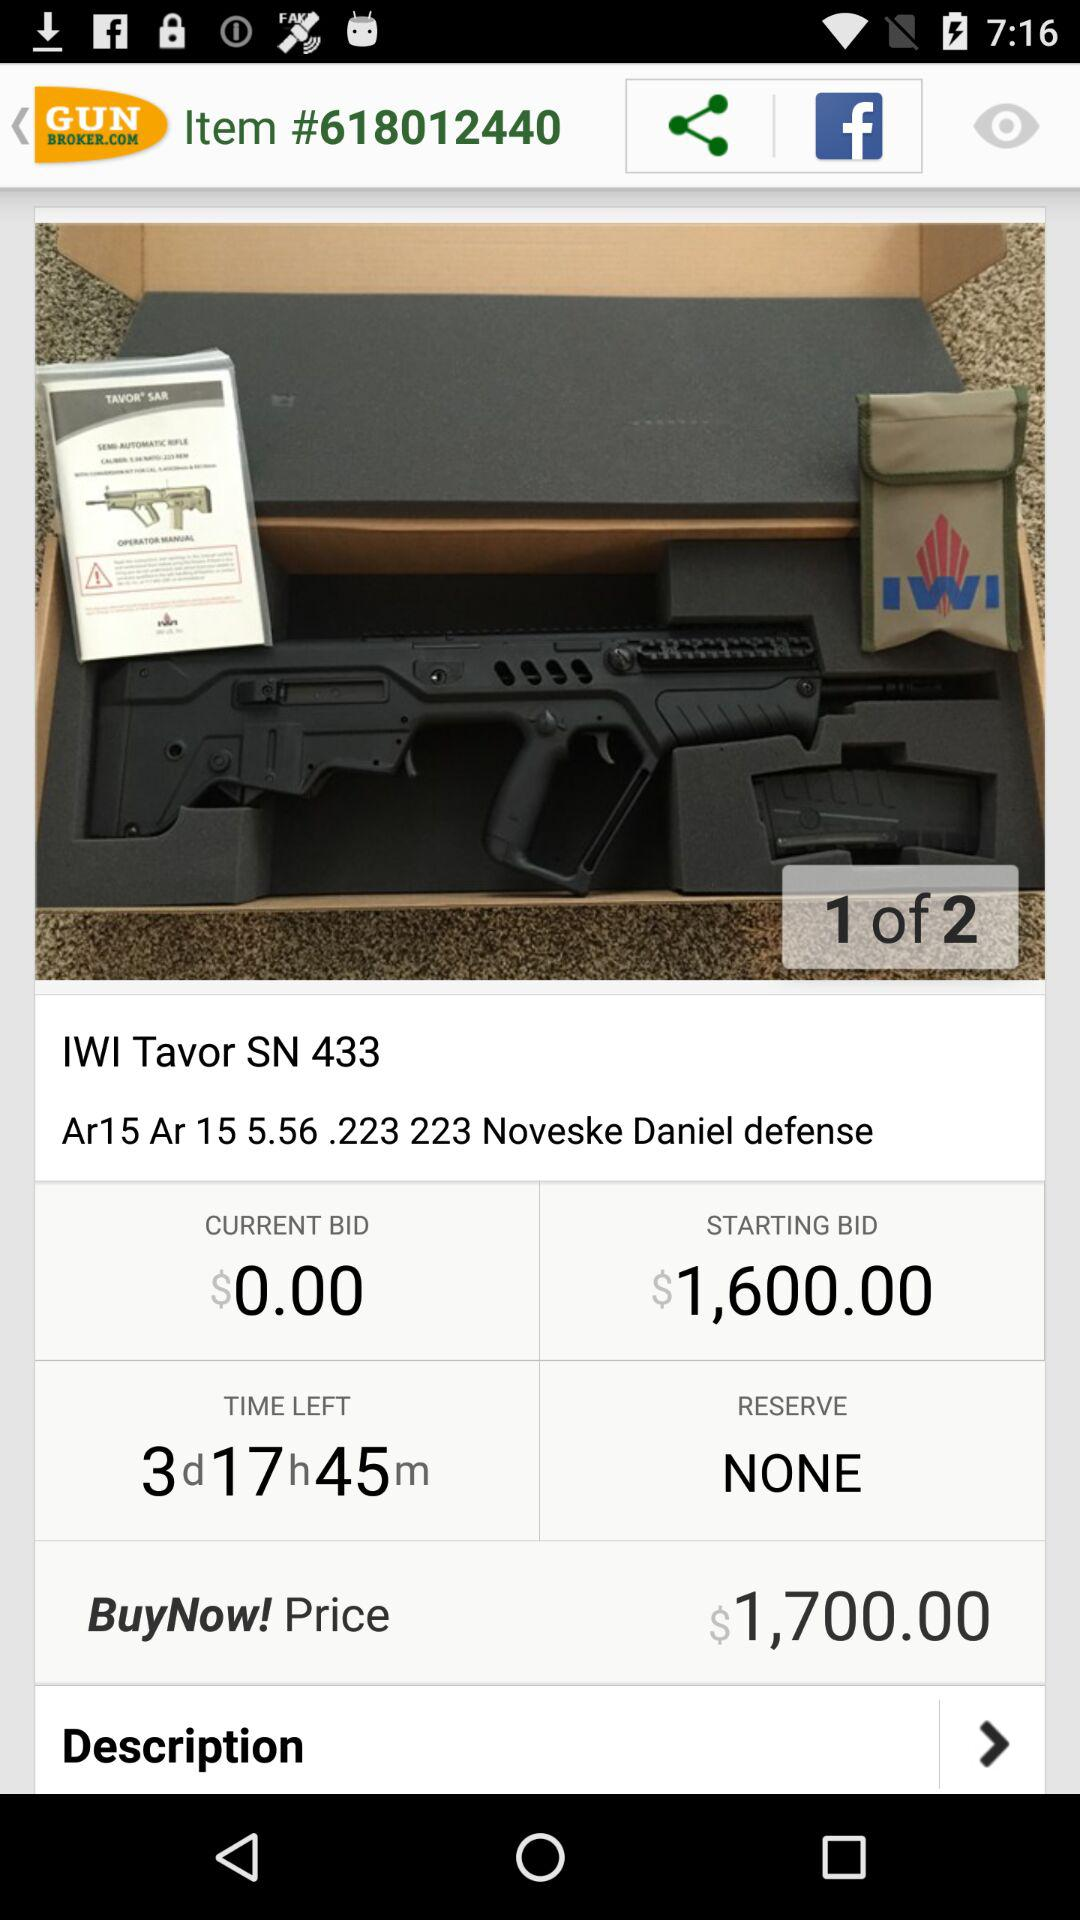How much more is the Buy Now price than the starting bid?
Answer the question using a single word or phrase. $100.00 